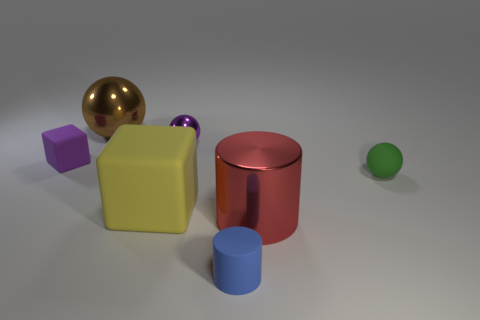What number of metallic objects are either large spheres or big red objects?
Ensure brevity in your answer.  2. How many purple metal balls are to the right of the small ball behind the green object in front of the tiny purple ball?
Keep it short and to the point. 0. What size is the green thing that is the same material as the tiny blue cylinder?
Give a very brief answer. Small. How many other tiny cylinders are the same color as the matte cylinder?
Keep it short and to the point. 0. There is a ball that is right of the matte cylinder; is its size the same as the tiny rubber block?
Your answer should be compact. Yes. There is a rubber thing that is both right of the purple metal sphere and left of the big red metallic cylinder; what is its color?
Your answer should be compact. Blue. How many objects are either green shiny blocks or tiny spheres that are in front of the purple matte thing?
Ensure brevity in your answer.  1. What is the big object that is behind the ball in front of the small purple thing on the left side of the large metallic ball made of?
Provide a short and direct response. Metal. Are there any other things that have the same material as the green thing?
Give a very brief answer. Yes. Does the tiny ball on the left side of the blue object have the same color as the small block?
Your answer should be compact. Yes. 